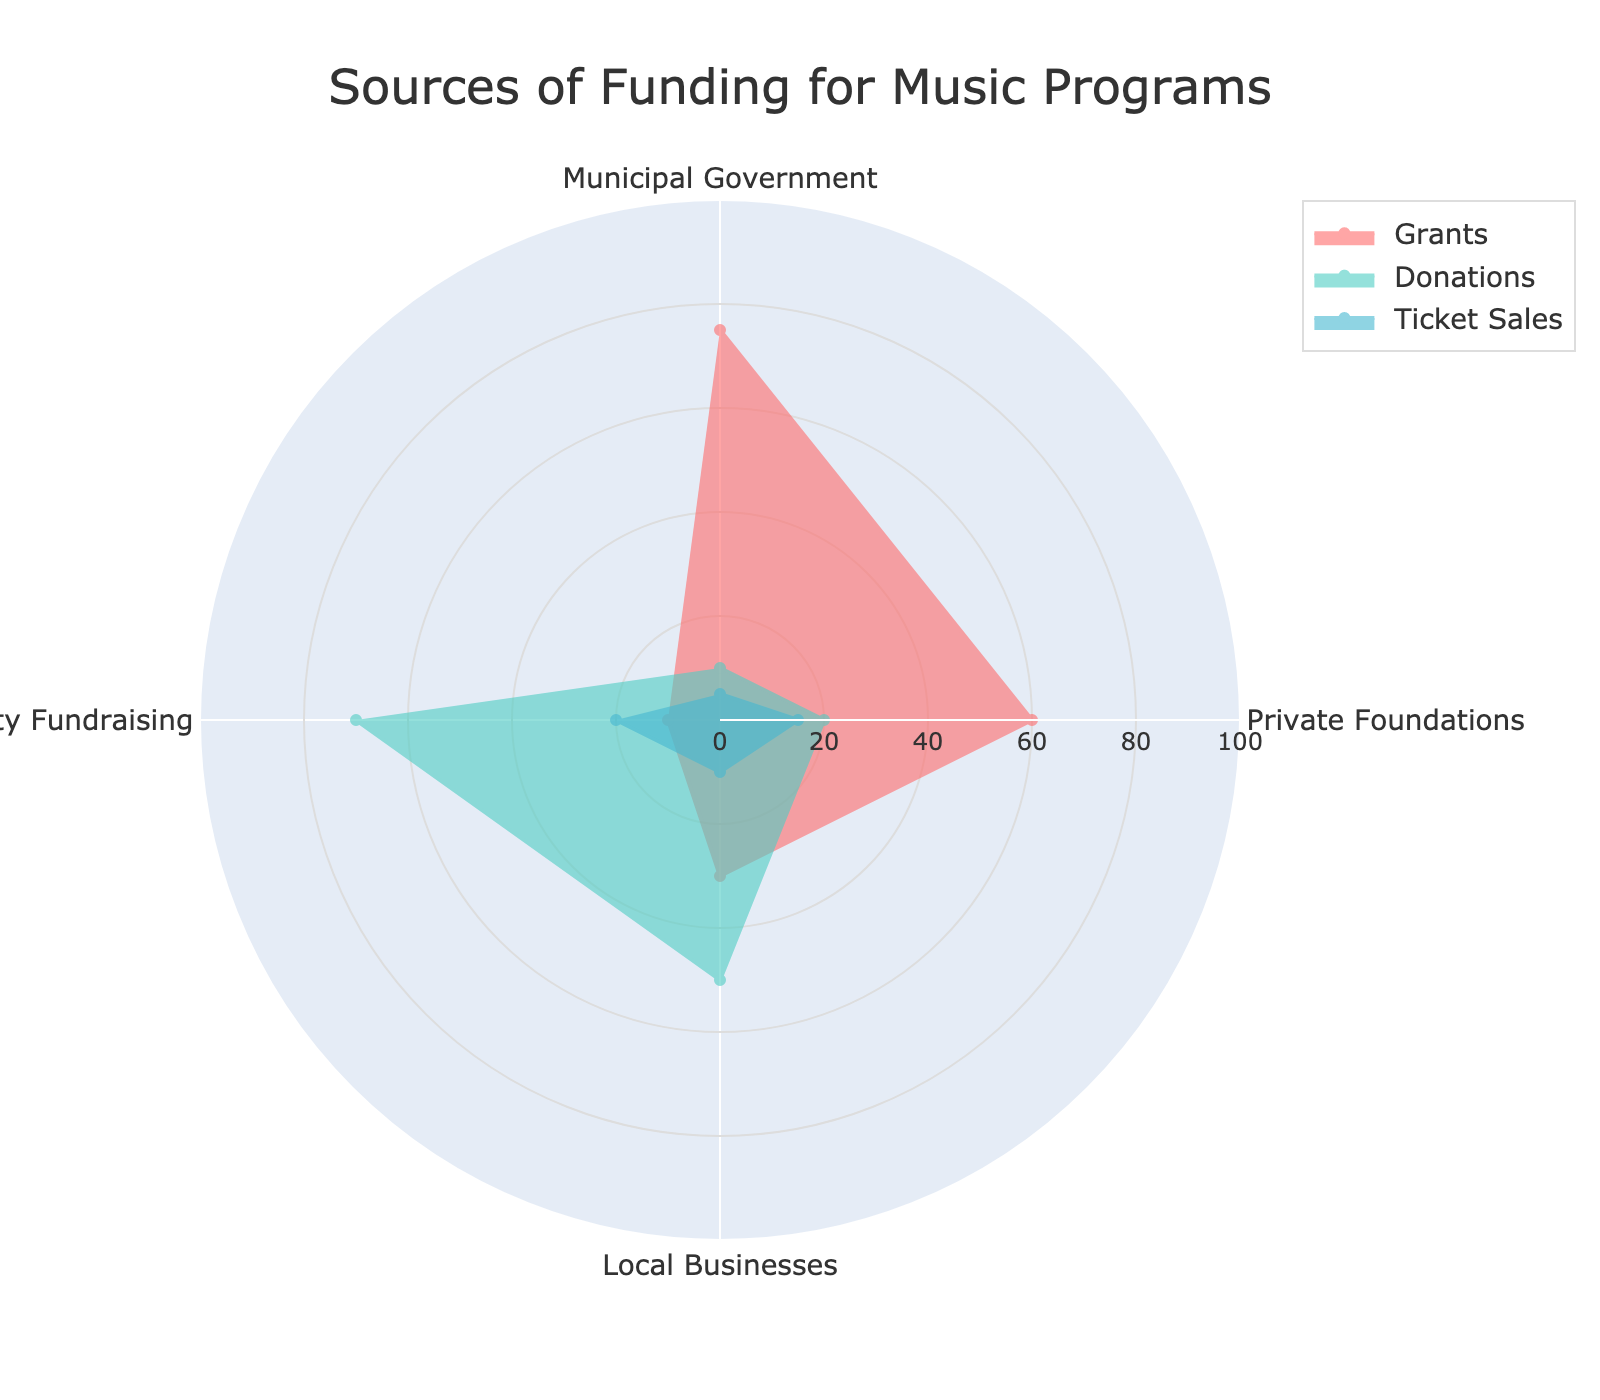what are the three sources of funding listed in the title? The title of the figure is 'Sources of Funding for Music Programs', indicating there are three sources mentioned here.
Answer: Grants, Donations, Ticket Sales Which group has the highest value for Donations? In the radar chart, the Donations group is represented by one particular color line. By visually examining the peaks for each entity (Municipal Government, Private Foundations, Local Businesses, Community Fundraising) under the Donations group, the highest value is found at the Community Fundraising point.
Answer: Community Fundraising By how much does the funding from Private Foundations exceed the funding from Local Businesses in the Ticket Sales group? Look at the values for Ticket Sales from Private Foundations and Local Businesses in the radar chart and subtract the smaller from the larger: 15 (Private Foundations) - 10 (Local Businesses) = 5.
Answer: 5 What is the average funding amount from Municipal Government? In the radar chart, find the value for Municipal Government under each group (Grants, Donations, Ticket Sales), sum them up, and divide by the number of groups: (75 + 10 + 5) / 3 = 90 / 3 = 30.
Answer: 30 What is the combined funding from Grants & Donations for Local Businesses? Find the values for Local Businesses under Grants and Donations, and sum them up: 30 (Grants) + 50 (Donations) = 80.
Answer: 80 Which source has the smallest minimum value across all groups? Check the minimum values of all groups (Grants, Donations, Ticket Sales) for each source and identify the smallest one. The smallest minimum is 5 from the Ticket Sales group in the Municipal Government source.
Answer: Municipal Government Which group has the greatest variation across all sources? Look at the range of values (maximum minus minimum) for each group (Grants, Donations, Ticket Sales). Calculate: for Grants (75 - 10) = 65, for Donations (70 - 10) = 60, for Ticket Sales (20 - 5) = 15. The greatest variation is in the Grants group.
Answer: Grants 